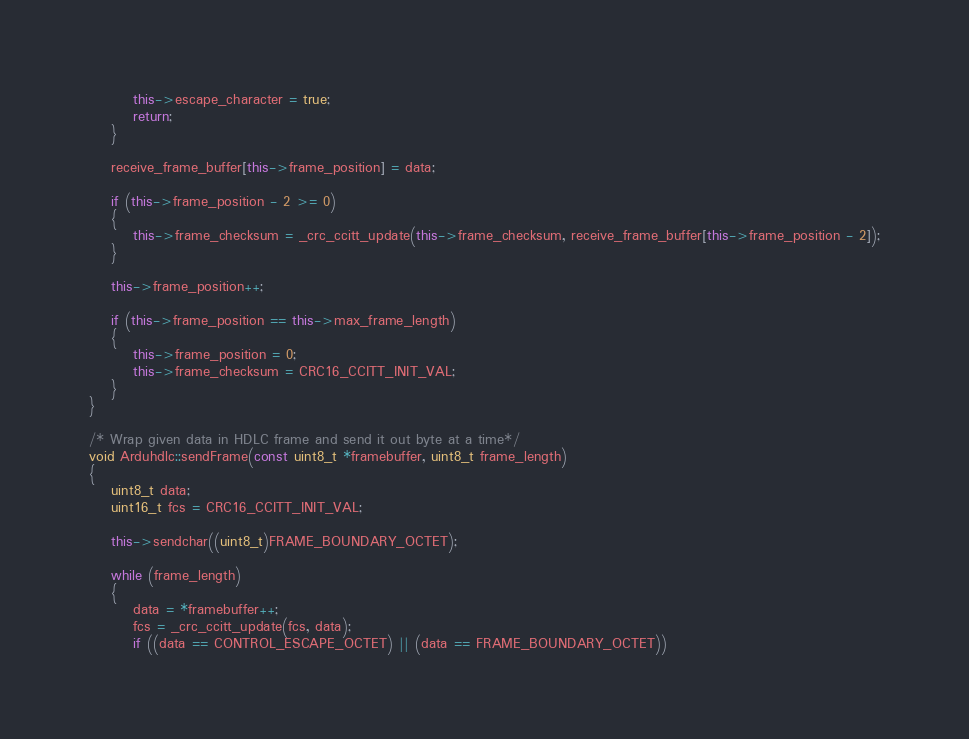Convert code to text. <code><loc_0><loc_0><loc_500><loc_500><_C++_>        this->escape_character = true;
        return;
    }

    receive_frame_buffer[this->frame_position] = data;

    if (this->frame_position - 2 >= 0)
    {
        this->frame_checksum = _crc_ccitt_update(this->frame_checksum, receive_frame_buffer[this->frame_position - 2]);
    }

    this->frame_position++;

    if (this->frame_position == this->max_frame_length)
    {
        this->frame_position = 0;
        this->frame_checksum = CRC16_CCITT_INIT_VAL;
    }
}

/* Wrap given data in HDLC frame and send it out byte at a time*/
void Arduhdlc::sendFrame(const uint8_t *framebuffer, uint8_t frame_length)
{
    uint8_t data;
    uint16_t fcs = CRC16_CCITT_INIT_VAL;

    this->sendchar((uint8_t)FRAME_BOUNDARY_OCTET);

    while (frame_length)
    {
        data = *framebuffer++;
        fcs = _crc_ccitt_update(fcs, data);
        if ((data == CONTROL_ESCAPE_OCTET) || (data == FRAME_BOUNDARY_OCTET))</code> 